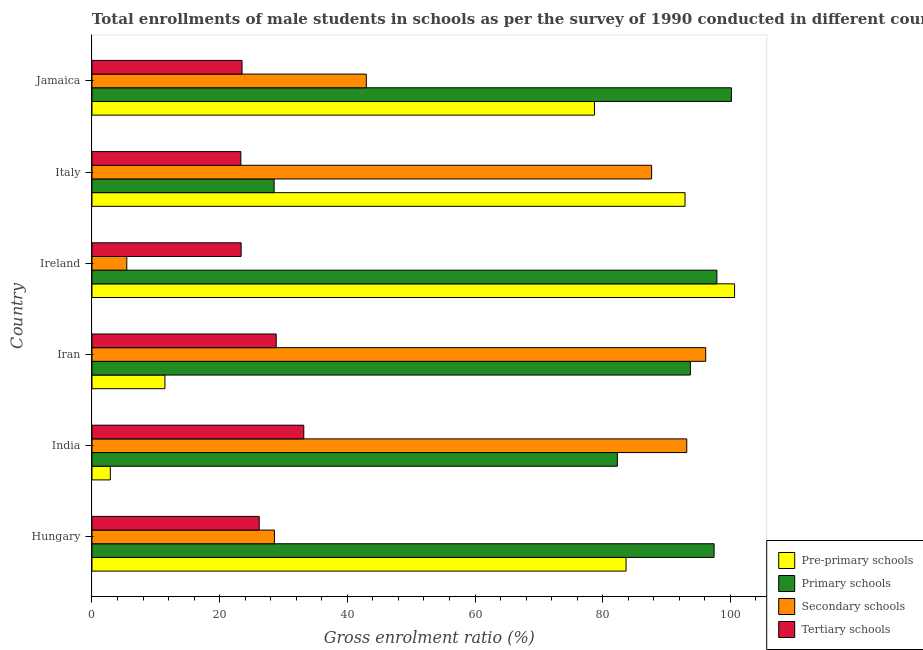Are the number of bars per tick equal to the number of legend labels?
Provide a succinct answer. Yes. Are the number of bars on each tick of the Y-axis equal?
Give a very brief answer. Yes. How many bars are there on the 1st tick from the top?
Give a very brief answer. 4. How many bars are there on the 4th tick from the bottom?
Provide a succinct answer. 4. What is the label of the 4th group of bars from the top?
Offer a terse response. Iran. In how many cases, is the number of bars for a given country not equal to the number of legend labels?
Your answer should be compact. 0. What is the gross enrolment ratio(male) in secondary schools in Italy?
Provide a succinct answer. 87.66. Across all countries, what is the maximum gross enrolment ratio(male) in pre-primary schools?
Provide a short and direct response. 100.66. Across all countries, what is the minimum gross enrolment ratio(male) in pre-primary schools?
Give a very brief answer. 2.87. In which country was the gross enrolment ratio(male) in pre-primary schools maximum?
Provide a short and direct response. Ireland. What is the total gross enrolment ratio(male) in primary schools in the graph?
Make the answer very short. 500.08. What is the difference between the gross enrolment ratio(male) in secondary schools in India and that in Ireland?
Offer a terse response. 87.72. What is the difference between the gross enrolment ratio(male) in pre-primary schools in Italy and the gross enrolment ratio(male) in secondary schools in India?
Offer a terse response. -0.27. What is the average gross enrolment ratio(male) in secondary schools per country?
Provide a short and direct response. 58.99. What is the difference between the gross enrolment ratio(male) in secondary schools and gross enrolment ratio(male) in pre-primary schools in Hungary?
Provide a succinct answer. -55.08. What is the ratio of the gross enrolment ratio(male) in pre-primary schools in Iran to that in Italy?
Your response must be concise. 0.12. Is the gross enrolment ratio(male) in primary schools in Iran less than that in Jamaica?
Ensure brevity in your answer.  Yes. Is the difference between the gross enrolment ratio(male) in secondary schools in Iran and Ireland greater than the difference between the gross enrolment ratio(male) in primary schools in Iran and Ireland?
Offer a very short reply. Yes. What is the difference between the highest and the second highest gross enrolment ratio(male) in tertiary schools?
Offer a very short reply. 4.32. What is the difference between the highest and the lowest gross enrolment ratio(male) in pre-primary schools?
Offer a very short reply. 97.78. In how many countries, is the gross enrolment ratio(male) in primary schools greater than the average gross enrolment ratio(male) in primary schools taken over all countries?
Give a very brief answer. 4. Is it the case that in every country, the sum of the gross enrolment ratio(male) in secondary schools and gross enrolment ratio(male) in tertiary schools is greater than the sum of gross enrolment ratio(male) in pre-primary schools and gross enrolment ratio(male) in primary schools?
Your answer should be compact. No. What does the 3rd bar from the top in Jamaica represents?
Provide a succinct answer. Primary schools. What does the 1st bar from the bottom in Ireland represents?
Offer a very short reply. Pre-primary schools. Is it the case that in every country, the sum of the gross enrolment ratio(male) in pre-primary schools and gross enrolment ratio(male) in primary schools is greater than the gross enrolment ratio(male) in secondary schools?
Provide a succinct answer. No. How many countries are there in the graph?
Offer a terse response. 6. Does the graph contain grids?
Offer a very short reply. No. How are the legend labels stacked?
Provide a succinct answer. Vertical. What is the title of the graph?
Give a very brief answer. Total enrollments of male students in schools as per the survey of 1990 conducted in different countries. Does "Bird species" appear as one of the legend labels in the graph?
Give a very brief answer. No. What is the label or title of the X-axis?
Provide a short and direct response. Gross enrolment ratio (%). What is the Gross enrolment ratio (%) in Pre-primary schools in Hungary?
Your answer should be very brief. 83.66. What is the Gross enrolment ratio (%) of Primary schools in Hungary?
Ensure brevity in your answer.  97.45. What is the Gross enrolment ratio (%) of Secondary schools in Hungary?
Provide a short and direct response. 28.58. What is the Gross enrolment ratio (%) of Tertiary schools in Hungary?
Keep it short and to the point. 26.19. What is the Gross enrolment ratio (%) of Pre-primary schools in India?
Your answer should be compact. 2.87. What is the Gross enrolment ratio (%) of Primary schools in India?
Your response must be concise. 82.3. What is the Gross enrolment ratio (%) in Secondary schools in India?
Offer a very short reply. 93.17. What is the Gross enrolment ratio (%) in Tertiary schools in India?
Your answer should be very brief. 33.18. What is the Gross enrolment ratio (%) in Pre-primary schools in Iran?
Offer a very short reply. 11.43. What is the Gross enrolment ratio (%) of Primary schools in Iran?
Ensure brevity in your answer.  93.74. What is the Gross enrolment ratio (%) in Secondary schools in Iran?
Provide a short and direct response. 96.13. What is the Gross enrolment ratio (%) in Tertiary schools in Iran?
Offer a very short reply. 28.86. What is the Gross enrolment ratio (%) of Pre-primary schools in Ireland?
Your response must be concise. 100.66. What is the Gross enrolment ratio (%) of Primary schools in Ireland?
Your response must be concise. 97.89. What is the Gross enrolment ratio (%) in Secondary schools in Ireland?
Offer a very short reply. 5.45. What is the Gross enrolment ratio (%) in Tertiary schools in Ireland?
Provide a succinct answer. 23.36. What is the Gross enrolment ratio (%) in Pre-primary schools in Italy?
Provide a succinct answer. 92.9. What is the Gross enrolment ratio (%) in Primary schools in Italy?
Make the answer very short. 28.54. What is the Gross enrolment ratio (%) in Secondary schools in Italy?
Your response must be concise. 87.66. What is the Gross enrolment ratio (%) of Tertiary schools in Italy?
Your response must be concise. 23.32. What is the Gross enrolment ratio (%) of Pre-primary schools in Jamaica?
Offer a terse response. 78.71. What is the Gross enrolment ratio (%) in Primary schools in Jamaica?
Offer a very short reply. 100.16. What is the Gross enrolment ratio (%) in Secondary schools in Jamaica?
Make the answer very short. 42.97. What is the Gross enrolment ratio (%) in Tertiary schools in Jamaica?
Offer a terse response. 23.51. Across all countries, what is the maximum Gross enrolment ratio (%) in Pre-primary schools?
Give a very brief answer. 100.66. Across all countries, what is the maximum Gross enrolment ratio (%) in Primary schools?
Give a very brief answer. 100.16. Across all countries, what is the maximum Gross enrolment ratio (%) in Secondary schools?
Provide a short and direct response. 96.13. Across all countries, what is the maximum Gross enrolment ratio (%) in Tertiary schools?
Offer a terse response. 33.18. Across all countries, what is the minimum Gross enrolment ratio (%) of Pre-primary schools?
Your response must be concise. 2.87. Across all countries, what is the minimum Gross enrolment ratio (%) in Primary schools?
Provide a short and direct response. 28.54. Across all countries, what is the minimum Gross enrolment ratio (%) in Secondary schools?
Ensure brevity in your answer.  5.45. Across all countries, what is the minimum Gross enrolment ratio (%) of Tertiary schools?
Keep it short and to the point. 23.32. What is the total Gross enrolment ratio (%) of Pre-primary schools in the graph?
Keep it short and to the point. 370.22. What is the total Gross enrolment ratio (%) in Primary schools in the graph?
Your response must be concise. 500.08. What is the total Gross enrolment ratio (%) of Secondary schools in the graph?
Keep it short and to the point. 353.97. What is the total Gross enrolment ratio (%) in Tertiary schools in the graph?
Offer a very short reply. 158.42. What is the difference between the Gross enrolment ratio (%) in Pre-primary schools in Hungary and that in India?
Provide a succinct answer. 80.78. What is the difference between the Gross enrolment ratio (%) in Primary schools in Hungary and that in India?
Your answer should be very brief. 15.15. What is the difference between the Gross enrolment ratio (%) in Secondary schools in Hungary and that in India?
Offer a very short reply. -64.59. What is the difference between the Gross enrolment ratio (%) in Tertiary schools in Hungary and that in India?
Provide a short and direct response. -6.98. What is the difference between the Gross enrolment ratio (%) of Pre-primary schools in Hungary and that in Iran?
Ensure brevity in your answer.  72.23. What is the difference between the Gross enrolment ratio (%) of Primary schools in Hungary and that in Iran?
Make the answer very short. 3.71. What is the difference between the Gross enrolment ratio (%) in Secondary schools in Hungary and that in Iran?
Keep it short and to the point. -67.56. What is the difference between the Gross enrolment ratio (%) in Tertiary schools in Hungary and that in Iran?
Provide a succinct answer. -2.66. What is the difference between the Gross enrolment ratio (%) in Pre-primary schools in Hungary and that in Ireland?
Offer a terse response. -17. What is the difference between the Gross enrolment ratio (%) in Primary schools in Hungary and that in Ireland?
Your answer should be very brief. -0.44. What is the difference between the Gross enrolment ratio (%) in Secondary schools in Hungary and that in Ireland?
Your answer should be compact. 23.12. What is the difference between the Gross enrolment ratio (%) of Tertiary schools in Hungary and that in Ireland?
Keep it short and to the point. 2.83. What is the difference between the Gross enrolment ratio (%) of Pre-primary schools in Hungary and that in Italy?
Provide a succinct answer. -9.24. What is the difference between the Gross enrolment ratio (%) of Primary schools in Hungary and that in Italy?
Your response must be concise. 68.91. What is the difference between the Gross enrolment ratio (%) of Secondary schools in Hungary and that in Italy?
Offer a very short reply. -59.09. What is the difference between the Gross enrolment ratio (%) of Tertiary schools in Hungary and that in Italy?
Offer a terse response. 2.87. What is the difference between the Gross enrolment ratio (%) in Pre-primary schools in Hungary and that in Jamaica?
Your answer should be compact. 4.95. What is the difference between the Gross enrolment ratio (%) in Primary schools in Hungary and that in Jamaica?
Provide a succinct answer. -2.71. What is the difference between the Gross enrolment ratio (%) in Secondary schools in Hungary and that in Jamaica?
Ensure brevity in your answer.  -14.39. What is the difference between the Gross enrolment ratio (%) in Tertiary schools in Hungary and that in Jamaica?
Offer a terse response. 2.69. What is the difference between the Gross enrolment ratio (%) of Pre-primary schools in India and that in Iran?
Your response must be concise. -8.55. What is the difference between the Gross enrolment ratio (%) of Primary schools in India and that in Iran?
Ensure brevity in your answer.  -11.44. What is the difference between the Gross enrolment ratio (%) in Secondary schools in India and that in Iran?
Provide a succinct answer. -2.97. What is the difference between the Gross enrolment ratio (%) in Tertiary schools in India and that in Iran?
Provide a succinct answer. 4.32. What is the difference between the Gross enrolment ratio (%) of Pre-primary schools in India and that in Ireland?
Provide a short and direct response. -97.78. What is the difference between the Gross enrolment ratio (%) in Primary schools in India and that in Ireland?
Your answer should be very brief. -15.59. What is the difference between the Gross enrolment ratio (%) of Secondary schools in India and that in Ireland?
Your response must be concise. 87.71. What is the difference between the Gross enrolment ratio (%) in Tertiary schools in India and that in Ireland?
Your answer should be very brief. 9.81. What is the difference between the Gross enrolment ratio (%) of Pre-primary schools in India and that in Italy?
Give a very brief answer. -90.02. What is the difference between the Gross enrolment ratio (%) of Primary schools in India and that in Italy?
Ensure brevity in your answer.  53.77. What is the difference between the Gross enrolment ratio (%) of Secondary schools in India and that in Italy?
Your answer should be compact. 5.51. What is the difference between the Gross enrolment ratio (%) of Tertiary schools in India and that in Italy?
Provide a succinct answer. 9.85. What is the difference between the Gross enrolment ratio (%) of Pre-primary schools in India and that in Jamaica?
Keep it short and to the point. -75.84. What is the difference between the Gross enrolment ratio (%) in Primary schools in India and that in Jamaica?
Your answer should be compact. -17.86. What is the difference between the Gross enrolment ratio (%) in Secondary schools in India and that in Jamaica?
Provide a short and direct response. 50.2. What is the difference between the Gross enrolment ratio (%) of Tertiary schools in India and that in Jamaica?
Ensure brevity in your answer.  9.67. What is the difference between the Gross enrolment ratio (%) of Pre-primary schools in Iran and that in Ireland?
Offer a terse response. -89.23. What is the difference between the Gross enrolment ratio (%) in Primary schools in Iran and that in Ireland?
Make the answer very short. -4.15. What is the difference between the Gross enrolment ratio (%) in Secondary schools in Iran and that in Ireland?
Give a very brief answer. 90.68. What is the difference between the Gross enrolment ratio (%) in Tertiary schools in Iran and that in Ireland?
Your answer should be very brief. 5.49. What is the difference between the Gross enrolment ratio (%) of Pre-primary schools in Iran and that in Italy?
Keep it short and to the point. -81.47. What is the difference between the Gross enrolment ratio (%) in Primary schools in Iran and that in Italy?
Give a very brief answer. 65.2. What is the difference between the Gross enrolment ratio (%) in Secondary schools in Iran and that in Italy?
Provide a short and direct response. 8.47. What is the difference between the Gross enrolment ratio (%) in Tertiary schools in Iran and that in Italy?
Your response must be concise. 5.54. What is the difference between the Gross enrolment ratio (%) of Pre-primary schools in Iran and that in Jamaica?
Your response must be concise. -67.28. What is the difference between the Gross enrolment ratio (%) of Primary schools in Iran and that in Jamaica?
Provide a succinct answer. -6.42. What is the difference between the Gross enrolment ratio (%) in Secondary schools in Iran and that in Jamaica?
Offer a terse response. 53.16. What is the difference between the Gross enrolment ratio (%) in Tertiary schools in Iran and that in Jamaica?
Offer a terse response. 5.35. What is the difference between the Gross enrolment ratio (%) in Pre-primary schools in Ireland and that in Italy?
Provide a short and direct response. 7.76. What is the difference between the Gross enrolment ratio (%) in Primary schools in Ireland and that in Italy?
Ensure brevity in your answer.  69.36. What is the difference between the Gross enrolment ratio (%) of Secondary schools in Ireland and that in Italy?
Give a very brief answer. -82.21. What is the difference between the Gross enrolment ratio (%) in Tertiary schools in Ireland and that in Italy?
Offer a terse response. 0.04. What is the difference between the Gross enrolment ratio (%) in Pre-primary schools in Ireland and that in Jamaica?
Your answer should be compact. 21.95. What is the difference between the Gross enrolment ratio (%) in Primary schools in Ireland and that in Jamaica?
Offer a terse response. -2.27. What is the difference between the Gross enrolment ratio (%) of Secondary schools in Ireland and that in Jamaica?
Give a very brief answer. -37.52. What is the difference between the Gross enrolment ratio (%) of Tertiary schools in Ireland and that in Jamaica?
Offer a very short reply. -0.14. What is the difference between the Gross enrolment ratio (%) of Pre-primary schools in Italy and that in Jamaica?
Keep it short and to the point. 14.19. What is the difference between the Gross enrolment ratio (%) in Primary schools in Italy and that in Jamaica?
Your answer should be very brief. -71.63. What is the difference between the Gross enrolment ratio (%) in Secondary schools in Italy and that in Jamaica?
Keep it short and to the point. 44.69. What is the difference between the Gross enrolment ratio (%) in Tertiary schools in Italy and that in Jamaica?
Your answer should be compact. -0.18. What is the difference between the Gross enrolment ratio (%) in Pre-primary schools in Hungary and the Gross enrolment ratio (%) in Primary schools in India?
Keep it short and to the point. 1.36. What is the difference between the Gross enrolment ratio (%) of Pre-primary schools in Hungary and the Gross enrolment ratio (%) of Secondary schools in India?
Offer a very short reply. -9.51. What is the difference between the Gross enrolment ratio (%) in Pre-primary schools in Hungary and the Gross enrolment ratio (%) in Tertiary schools in India?
Your response must be concise. 50.48. What is the difference between the Gross enrolment ratio (%) of Primary schools in Hungary and the Gross enrolment ratio (%) of Secondary schools in India?
Provide a short and direct response. 4.28. What is the difference between the Gross enrolment ratio (%) of Primary schools in Hungary and the Gross enrolment ratio (%) of Tertiary schools in India?
Give a very brief answer. 64.27. What is the difference between the Gross enrolment ratio (%) in Secondary schools in Hungary and the Gross enrolment ratio (%) in Tertiary schools in India?
Provide a short and direct response. -4.6. What is the difference between the Gross enrolment ratio (%) of Pre-primary schools in Hungary and the Gross enrolment ratio (%) of Primary schools in Iran?
Offer a terse response. -10.08. What is the difference between the Gross enrolment ratio (%) in Pre-primary schools in Hungary and the Gross enrolment ratio (%) in Secondary schools in Iran?
Your answer should be very brief. -12.48. What is the difference between the Gross enrolment ratio (%) in Pre-primary schools in Hungary and the Gross enrolment ratio (%) in Tertiary schools in Iran?
Offer a very short reply. 54.8. What is the difference between the Gross enrolment ratio (%) of Primary schools in Hungary and the Gross enrolment ratio (%) of Secondary schools in Iran?
Ensure brevity in your answer.  1.31. What is the difference between the Gross enrolment ratio (%) of Primary schools in Hungary and the Gross enrolment ratio (%) of Tertiary schools in Iran?
Your answer should be compact. 68.59. What is the difference between the Gross enrolment ratio (%) in Secondary schools in Hungary and the Gross enrolment ratio (%) in Tertiary schools in Iran?
Provide a succinct answer. -0.28. What is the difference between the Gross enrolment ratio (%) of Pre-primary schools in Hungary and the Gross enrolment ratio (%) of Primary schools in Ireland?
Give a very brief answer. -14.23. What is the difference between the Gross enrolment ratio (%) of Pre-primary schools in Hungary and the Gross enrolment ratio (%) of Secondary schools in Ireland?
Your answer should be compact. 78.2. What is the difference between the Gross enrolment ratio (%) in Pre-primary schools in Hungary and the Gross enrolment ratio (%) in Tertiary schools in Ireland?
Make the answer very short. 60.29. What is the difference between the Gross enrolment ratio (%) of Primary schools in Hungary and the Gross enrolment ratio (%) of Secondary schools in Ireland?
Make the answer very short. 92. What is the difference between the Gross enrolment ratio (%) in Primary schools in Hungary and the Gross enrolment ratio (%) in Tertiary schools in Ireland?
Give a very brief answer. 74.09. What is the difference between the Gross enrolment ratio (%) in Secondary schools in Hungary and the Gross enrolment ratio (%) in Tertiary schools in Ireland?
Your response must be concise. 5.21. What is the difference between the Gross enrolment ratio (%) of Pre-primary schools in Hungary and the Gross enrolment ratio (%) of Primary schools in Italy?
Make the answer very short. 55.12. What is the difference between the Gross enrolment ratio (%) of Pre-primary schools in Hungary and the Gross enrolment ratio (%) of Secondary schools in Italy?
Your answer should be compact. -4. What is the difference between the Gross enrolment ratio (%) of Pre-primary schools in Hungary and the Gross enrolment ratio (%) of Tertiary schools in Italy?
Give a very brief answer. 60.34. What is the difference between the Gross enrolment ratio (%) in Primary schools in Hungary and the Gross enrolment ratio (%) in Secondary schools in Italy?
Offer a terse response. 9.79. What is the difference between the Gross enrolment ratio (%) in Primary schools in Hungary and the Gross enrolment ratio (%) in Tertiary schools in Italy?
Your answer should be compact. 74.13. What is the difference between the Gross enrolment ratio (%) in Secondary schools in Hungary and the Gross enrolment ratio (%) in Tertiary schools in Italy?
Make the answer very short. 5.25. What is the difference between the Gross enrolment ratio (%) in Pre-primary schools in Hungary and the Gross enrolment ratio (%) in Primary schools in Jamaica?
Provide a short and direct response. -16.5. What is the difference between the Gross enrolment ratio (%) of Pre-primary schools in Hungary and the Gross enrolment ratio (%) of Secondary schools in Jamaica?
Provide a succinct answer. 40.69. What is the difference between the Gross enrolment ratio (%) of Pre-primary schools in Hungary and the Gross enrolment ratio (%) of Tertiary schools in Jamaica?
Your response must be concise. 60.15. What is the difference between the Gross enrolment ratio (%) in Primary schools in Hungary and the Gross enrolment ratio (%) in Secondary schools in Jamaica?
Your answer should be compact. 54.48. What is the difference between the Gross enrolment ratio (%) in Primary schools in Hungary and the Gross enrolment ratio (%) in Tertiary schools in Jamaica?
Your answer should be very brief. 73.94. What is the difference between the Gross enrolment ratio (%) of Secondary schools in Hungary and the Gross enrolment ratio (%) of Tertiary schools in Jamaica?
Ensure brevity in your answer.  5.07. What is the difference between the Gross enrolment ratio (%) of Pre-primary schools in India and the Gross enrolment ratio (%) of Primary schools in Iran?
Provide a succinct answer. -90.86. What is the difference between the Gross enrolment ratio (%) of Pre-primary schools in India and the Gross enrolment ratio (%) of Secondary schools in Iran?
Give a very brief answer. -93.26. What is the difference between the Gross enrolment ratio (%) in Pre-primary schools in India and the Gross enrolment ratio (%) in Tertiary schools in Iran?
Provide a succinct answer. -25.98. What is the difference between the Gross enrolment ratio (%) of Primary schools in India and the Gross enrolment ratio (%) of Secondary schools in Iran?
Keep it short and to the point. -13.83. What is the difference between the Gross enrolment ratio (%) of Primary schools in India and the Gross enrolment ratio (%) of Tertiary schools in Iran?
Your answer should be compact. 53.44. What is the difference between the Gross enrolment ratio (%) of Secondary schools in India and the Gross enrolment ratio (%) of Tertiary schools in Iran?
Your answer should be compact. 64.31. What is the difference between the Gross enrolment ratio (%) of Pre-primary schools in India and the Gross enrolment ratio (%) of Primary schools in Ireland?
Provide a short and direct response. -95.02. What is the difference between the Gross enrolment ratio (%) of Pre-primary schools in India and the Gross enrolment ratio (%) of Secondary schools in Ireland?
Provide a succinct answer. -2.58. What is the difference between the Gross enrolment ratio (%) of Pre-primary schools in India and the Gross enrolment ratio (%) of Tertiary schools in Ireland?
Provide a succinct answer. -20.49. What is the difference between the Gross enrolment ratio (%) of Primary schools in India and the Gross enrolment ratio (%) of Secondary schools in Ireland?
Provide a succinct answer. 76.85. What is the difference between the Gross enrolment ratio (%) of Primary schools in India and the Gross enrolment ratio (%) of Tertiary schools in Ireland?
Make the answer very short. 58.94. What is the difference between the Gross enrolment ratio (%) in Secondary schools in India and the Gross enrolment ratio (%) in Tertiary schools in Ireland?
Ensure brevity in your answer.  69.81. What is the difference between the Gross enrolment ratio (%) in Pre-primary schools in India and the Gross enrolment ratio (%) in Primary schools in Italy?
Ensure brevity in your answer.  -25.66. What is the difference between the Gross enrolment ratio (%) in Pre-primary schools in India and the Gross enrolment ratio (%) in Secondary schools in Italy?
Provide a succinct answer. -84.79. What is the difference between the Gross enrolment ratio (%) of Pre-primary schools in India and the Gross enrolment ratio (%) of Tertiary schools in Italy?
Offer a very short reply. -20.45. What is the difference between the Gross enrolment ratio (%) in Primary schools in India and the Gross enrolment ratio (%) in Secondary schools in Italy?
Your answer should be compact. -5.36. What is the difference between the Gross enrolment ratio (%) in Primary schools in India and the Gross enrolment ratio (%) in Tertiary schools in Italy?
Provide a succinct answer. 58.98. What is the difference between the Gross enrolment ratio (%) of Secondary schools in India and the Gross enrolment ratio (%) of Tertiary schools in Italy?
Your answer should be compact. 69.85. What is the difference between the Gross enrolment ratio (%) of Pre-primary schools in India and the Gross enrolment ratio (%) of Primary schools in Jamaica?
Your answer should be very brief. -97.29. What is the difference between the Gross enrolment ratio (%) in Pre-primary schools in India and the Gross enrolment ratio (%) in Secondary schools in Jamaica?
Keep it short and to the point. -40.1. What is the difference between the Gross enrolment ratio (%) of Pre-primary schools in India and the Gross enrolment ratio (%) of Tertiary schools in Jamaica?
Ensure brevity in your answer.  -20.63. What is the difference between the Gross enrolment ratio (%) in Primary schools in India and the Gross enrolment ratio (%) in Secondary schools in Jamaica?
Your answer should be very brief. 39.33. What is the difference between the Gross enrolment ratio (%) of Primary schools in India and the Gross enrolment ratio (%) of Tertiary schools in Jamaica?
Give a very brief answer. 58.79. What is the difference between the Gross enrolment ratio (%) of Secondary schools in India and the Gross enrolment ratio (%) of Tertiary schools in Jamaica?
Your answer should be very brief. 69.66. What is the difference between the Gross enrolment ratio (%) of Pre-primary schools in Iran and the Gross enrolment ratio (%) of Primary schools in Ireland?
Offer a very short reply. -86.46. What is the difference between the Gross enrolment ratio (%) in Pre-primary schools in Iran and the Gross enrolment ratio (%) in Secondary schools in Ireland?
Give a very brief answer. 5.97. What is the difference between the Gross enrolment ratio (%) in Pre-primary schools in Iran and the Gross enrolment ratio (%) in Tertiary schools in Ireland?
Offer a very short reply. -11.93. What is the difference between the Gross enrolment ratio (%) of Primary schools in Iran and the Gross enrolment ratio (%) of Secondary schools in Ireland?
Ensure brevity in your answer.  88.28. What is the difference between the Gross enrolment ratio (%) of Primary schools in Iran and the Gross enrolment ratio (%) of Tertiary schools in Ireland?
Offer a terse response. 70.37. What is the difference between the Gross enrolment ratio (%) of Secondary schools in Iran and the Gross enrolment ratio (%) of Tertiary schools in Ireland?
Make the answer very short. 72.77. What is the difference between the Gross enrolment ratio (%) of Pre-primary schools in Iran and the Gross enrolment ratio (%) of Primary schools in Italy?
Give a very brief answer. -17.11. What is the difference between the Gross enrolment ratio (%) of Pre-primary schools in Iran and the Gross enrolment ratio (%) of Secondary schools in Italy?
Provide a succinct answer. -76.23. What is the difference between the Gross enrolment ratio (%) of Pre-primary schools in Iran and the Gross enrolment ratio (%) of Tertiary schools in Italy?
Give a very brief answer. -11.89. What is the difference between the Gross enrolment ratio (%) of Primary schools in Iran and the Gross enrolment ratio (%) of Secondary schools in Italy?
Make the answer very short. 6.08. What is the difference between the Gross enrolment ratio (%) of Primary schools in Iran and the Gross enrolment ratio (%) of Tertiary schools in Italy?
Offer a terse response. 70.42. What is the difference between the Gross enrolment ratio (%) in Secondary schools in Iran and the Gross enrolment ratio (%) in Tertiary schools in Italy?
Provide a short and direct response. 72.81. What is the difference between the Gross enrolment ratio (%) in Pre-primary schools in Iran and the Gross enrolment ratio (%) in Primary schools in Jamaica?
Give a very brief answer. -88.73. What is the difference between the Gross enrolment ratio (%) in Pre-primary schools in Iran and the Gross enrolment ratio (%) in Secondary schools in Jamaica?
Provide a succinct answer. -31.54. What is the difference between the Gross enrolment ratio (%) in Pre-primary schools in Iran and the Gross enrolment ratio (%) in Tertiary schools in Jamaica?
Your answer should be compact. -12.08. What is the difference between the Gross enrolment ratio (%) of Primary schools in Iran and the Gross enrolment ratio (%) of Secondary schools in Jamaica?
Keep it short and to the point. 50.77. What is the difference between the Gross enrolment ratio (%) of Primary schools in Iran and the Gross enrolment ratio (%) of Tertiary schools in Jamaica?
Your answer should be compact. 70.23. What is the difference between the Gross enrolment ratio (%) in Secondary schools in Iran and the Gross enrolment ratio (%) in Tertiary schools in Jamaica?
Provide a succinct answer. 72.63. What is the difference between the Gross enrolment ratio (%) in Pre-primary schools in Ireland and the Gross enrolment ratio (%) in Primary schools in Italy?
Your answer should be very brief. 72.12. What is the difference between the Gross enrolment ratio (%) in Pre-primary schools in Ireland and the Gross enrolment ratio (%) in Secondary schools in Italy?
Your answer should be compact. 12.99. What is the difference between the Gross enrolment ratio (%) of Pre-primary schools in Ireland and the Gross enrolment ratio (%) of Tertiary schools in Italy?
Keep it short and to the point. 77.34. What is the difference between the Gross enrolment ratio (%) in Primary schools in Ireland and the Gross enrolment ratio (%) in Secondary schools in Italy?
Offer a very short reply. 10.23. What is the difference between the Gross enrolment ratio (%) in Primary schools in Ireland and the Gross enrolment ratio (%) in Tertiary schools in Italy?
Your response must be concise. 74.57. What is the difference between the Gross enrolment ratio (%) of Secondary schools in Ireland and the Gross enrolment ratio (%) of Tertiary schools in Italy?
Your response must be concise. -17.87. What is the difference between the Gross enrolment ratio (%) in Pre-primary schools in Ireland and the Gross enrolment ratio (%) in Primary schools in Jamaica?
Provide a succinct answer. 0.5. What is the difference between the Gross enrolment ratio (%) of Pre-primary schools in Ireland and the Gross enrolment ratio (%) of Secondary schools in Jamaica?
Offer a terse response. 57.69. What is the difference between the Gross enrolment ratio (%) in Pre-primary schools in Ireland and the Gross enrolment ratio (%) in Tertiary schools in Jamaica?
Your answer should be very brief. 77.15. What is the difference between the Gross enrolment ratio (%) in Primary schools in Ireland and the Gross enrolment ratio (%) in Secondary schools in Jamaica?
Provide a short and direct response. 54.92. What is the difference between the Gross enrolment ratio (%) of Primary schools in Ireland and the Gross enrolment ratio (%) of Tertiary schools in Jamaica?
Offer a very short reply. 74.39. What is the difference between the Gross enrolment ratio (%) of Secondary schools in Ireland and the Gross enrolment ratio (%) of Tertiary schools in Jamaica?
Provide a succinct answer. -18.05. What is the difference between the Gross enrolment ratio (%) of Pre-primary schools in Italy and the Gross enrolment ratio (%) of Primary schools in Jamaica?
Keep it short and to the point. -7.26. What is the difference between the Gross enrolment ratio (%) of Pre-primary schools in Italy and the Gross enrolment ratio (%) of Secondary schools in Jamaica?
Provide a short and direct response. 49.93. What is the difference between the Gross enrolment ratio (%) of Pre-primary schools in Italy and the Gross enrolment ratio (%) of Tertiary schools in Jamaica?
Keep it short and to the point. 69.39. What is the difference between the Gross enrolment ratio (%) of Primary schools in Italy and the Gross enrolment ratio (%) of Secondary schools in Jamaica?
Ensure brevity in your answer.  -14.44. What is the difference between the Gross enrolment ratio (%) of Primary schools in Italy and the Gross enrolment ratio (%) of Tertiary schools in Jamaica?
Provide a short and direct response. 5.03. What is the difference between the Gross enrolment ratio (%) in Secondary schools in Italy and the Gross enrolment ratio (%) in Tertiary schools in Jamaica?
Your answer should be very brief. 64.16. What is the average Gross enrolment ratio (%) of Pre-primary schools per country?
Provide a short and direct response. 61.7. What is the average Gross enrolment ratio (%) in Primary schools per country?
Make the answer very short. 83.35. What is the average Gross enrolment ratio (%) of Secondary schools per country?
Give a very brief answer. 58.99. What is the average Gross enrolment ratio (%) in Tertiary schools per country?
Provide a short and direct response. 26.4. What is the difference between the Gross enrolment ratio (%) in Pre-primary schools and Gross enrolment ratio (%) in Primary schools in Hungary?
Make the answer very short. -13.79. What is the difference between the Gross enrolment ratio (%) in Pre-primary schools and Gross enrolment ratio (%) in Secondary schools in Hungary?
Your answer should be compact. 55.08. What is the difference between the Gross enrolment ratio (%) of Pre-primary schools and Gross enrolment ratio (%) of Tertiary schools in Hungary?
Your response must be concise. 57.46. What is the difference between the Gross enrolment ratio (%) in Primary schools and Gross enrolment ratio (%) in Secondary schools in Hungary?
Offer a very short reply. 68.87. What is the difference between the Gross enrolment ratio (%) of Primary schools and Gross enrolment ratio (%) of Tertiary schools in Hungary?
Provide a succinct answer. 71.26. What is the difference between the Gross enrolment ratio (%) of Secondary schools and Gross enrolment ratio (%) of Tertiary schools in Hungary?
Provide a short and direct response. 2.38. What is the difference between the Gross enrolment ratio (%) in Pre-primary schools and Gross enrolment ratio (%) in Primary schools in India?
Offer a very short reply. -79.43. What is the difference between the Gross enrolment ratio (%) of Pre-primary schools and Gross enrolment ratio (%) of Secondary schools in India?
Keep it short and to the point. -90.3. What is the difference between the Gross enrolment ratio (%) of Pre-primary schools and Gross enrolment ratio (%) of Tertiary schools in India?
Your answer should be compact. -30.3. What is the difference between the Gross enrolment ratio (%) in Primary schools and Gross enrolment ratio (%) in Secondary schools in India?
Keep it short and to the point. -10.87. What is the difference between the Gross enrolment ratio (%) of Primary schools and Gross enrolment ratio (%) of Tertiary schools in India?
Offer a very short reply. 49.12. What is the difference between the Gross enrolment ratio (%) of Secondary schools and Gross enrolment ratio (%) of Tertiary schools in India?
Provide a succinct answer. 59.99. What is the difference between the Gross enrolment ratio (%) of Pre-primary schools and Gross enrolment ratio (%) of Primary schools in Iran?
Your answer should be very brief. -82.31. What is the difference between the Gross enrolment ratio (%) of Pre-primary schools and Gross enrolment ratio (%) of Secondary schools in Iran?
Offer a very short reply. -84.71. What is the difference between the Gross enrolment ratio (%) of Pre-primary schools and Gross enrolment ratio (%) of Tertiary schools in Iran?
Your answer should be very brief. -17.43. What is the difference between the Gross enrolment ratio (%) in Primary schools and Gross enrolment ratio (%) in Secondary schools in Iran?
Offer a terse response. -2.4. What is the difference between the Gross enrolment ratio (%) of Primary schools and Gross enrolment ratio (%) of Tertiary schools in Iran?
Provide a succinct answer. 64.88. What is the difference between the Gross enrolment ratio (%) of Secondary schools and Gross enrolment ratio (%) of Tertiary schools in Iran?
Keep it short and to the point. 67.28. What is the difference between the Gross enrolment ratio (%) of Pre-primary schools and Gross enrolment ratio (%) of Primary schools in Ireland?
Make the answer very short. 2.77. What is the difference between the Gross enrolment ratio (%) in Pre-primary schools and Gross enrolment ratio (%) in Secondary schools in Ireland?
Provide a succinct answer. 95.2. What is the difference between the Gross enrolment ratio (%) of Pre-primary schools and Gross enrolment ratio (%) of Tertiary schools in Ireland?
Give a very brief answer. 77.29. What is the difference between the Gross enrolment ratio (%) in Primary schools and Gross enrolment ratio (%) in Secondary schools in Ireland?
Your answer should be very brief. 92.44. What is the difference between the Gross enrolment ratio (%) of Primary schools and Gross enrolment ratio (%) of Tertiary schools in Ireland?
Make the answer very short. 74.53. What is the difference between the Gross enrolment ratio (%) in Secondary schools and Gross enrolment ratio (%) in Tertiary schools in Ireland?
Offer a terse response. -17.91. What is the difference between the Gross enrolment ratio (%) in Pre-primary schools and Gross enrolment ratio (%) in Primary schools in Italy?
Make the answer very short. 64.36. What is the difference between the Gross enrolment ratio (%) of Pre-primary schools and Gross enrolment ratio (%) of Secondary schools in Italy?
Your response must be concise. 5.24. What is the difference between the Gross enrolment ratio (%) in Pre-primary schools and Gross enrolment ratio (%) in Tertiary schools in Italy?
Ensure brevity in your answer.  69.58. What is the difference between the Gross enrolment ratio (%) of Primary schools and Gross enrolment ratio (%) of Secondary schools in Italy?
Give a very brief answer. -59.13. What is the difference between the Gross enrolment ratio (%) of Primary schools and Gross enrolment ratio (%) of Tertiary schools in Italy?
Your response must be concise. 5.21. What is the difference between the Gross enrolment ratio (%) of Secondary schools and Gross enrolment ratio (%) of Tertiary schools in Italy?
Offer a terse response. 64.34. What is the difference between the Gross enrolment ratio (%) of Pre-primary schools and Gross enrolment ratio (%) of Primary schools in Jamaica?
Your response must be concise. -21.45. What is the difference between the Gross enrolment ratio (%) of Pre-primary schools and Gross enrolment ratio (%) of Secondary schools in Jamaica?
Offer a terse response. 35.74. What is the difference between the Gross enrolment ratio (%) in Pre-primary schools and Gross enrolment ratio (%) in Tertiary schools in Jamaica?
Offer a very short reply. 55.2. What is the difference between the Gross enrolment ratio (%) in Primary schools and Gross enrolment ratio (%) in Secondary schools in Jamaica?
Offer a very short reply. 57.19. What is the difference between the Gross enrolment ratio (%) of Primary schools and Gross enrolment ratio (%) of Tertiary schools in Jamaica?
Your answer should be very brief. 76.66. What is the difference between the Gross enrolment ratio (%) of Secondary schools and Gross enrolment ratio (%) of Tertiary schools in Jamaica?
Your answer should be compact. 19.46. What is the ratio of the Gross enrolment ratio (%) in Pre-primary schools in Hungary to that in India?
Ensure brevity in your answer.  29.11. What is the ratio of the Gross enrolment ratio (%) of Primary schools in Hungary to that in India?
Offer a terse response. 1.18. What is the ratio of the Gross enrolment ratio (%) of Secondary schools in Hungary to that in India?
Your answer should be compact. 0.31. What is the ratio of the Gross enrolment ratio (%) in Tertiary schools in Hungary to that in India?
Ensure brevity in your answer.  0.79. What is the ratio of the Gross enrolment ratio (%) of Pre-primary schools in Hungary to that in Iran?
Give a very brief answer. 7.32. What is the ratio of the Gross enrolment ratio (%) in Primary schools in Hungary to that in Iran?
Your response must be concise. 1.04. What is the ratio of the Gross enrolment ratio (%) of Secondary schools in Hungary to that in Iran?
Ensure brevity in your answer.  0.3. What is the ratio of the Gross enrolment ratio (%) of Tertiary schools in Hungary to that in Iran?
Your answer should be compact. 0.91. What is the ratio of the Gross enrolment ratio (%) in Pre-primary schools in Hungary to that in Ireland?
Provide a succinct answer. 0.83. What is the ratio of the Gross enrolment ratio (%) of Primary schools in Hungary to that in Ireland?
Give a very brief answer. 1. What is the ratio of the Gross enrolment ratio (%) in Secondary schools in Hungary to that in Ireland?
Provide a short and direct response. 5.24. What is the ratio of the Gross enrolment ratio (%) of Tertiary schools in Hungary to that in Ireland?
Provide a succinct answer. 1.12. What is the ratio of the Gross enrolment ratio (%) in Pre-primary schools in Hungary to that in Italy?
Offer a very short reply. 0.9. What is the ratio of the Gross enrolment ratio (%) in Primary schools in Hungary to that in Italy?
Your answer should be compact. 3.42. What is the ratio of the Gross enrolment ratio (%) in Secondary schools in Hungary to that in Italy?
Ensure brevity in your answer.  0.33. What is the ratio of the Gross enrolment ratio (%) in Tertiary schools in Hungary to that in Italy?
Keep it short and to the point. 1.12. What is the ratio of the Gross enrolment ratio (%) of Pre-primary schools in Hungary to that in Jamaica?
Give a very brief answer. 1.06. What is the ratio of the Gross enrolment ratio (%) of Primary schools in Hungary to that in Jamaica?
Offer a terse response. 0.97. What is the ratio of the Gross enrolment ratio (%) of Secondary schools in Hungary to that in Jamaica?
Ensure brevity in your answer.  0.67. What is the ratio of the Gross enrolment ratio (%) in Tertiary schools in Hungary to that in Jamaica?
Your answer should be very brief. 1.11. What is the ratio of the Gross enrolment ratio (%) of Pre-primary schools in India to that in Iran?
Your response must be concise. 0.25. What is the ratio of the Gross enrolment ratio (%) in Primary schools in India to that in Iran?
Offer a terse response. 0.88. What is the ratio of the Gross enrolment ratio (%) in Secondary schools in India to that in Iran?
Make the answer very short. 0.97. What is the ratio of the Gross enrolment ratio (%) of Tertiary schools in India to that in Iran?
Keep it short and to the point. 1.15. What is the ratio of the Gross enrolment ratio (%) of Pre-primary schools in India to that in Ireland?
Give a very brief answer. 0.03. What is the ratio of the Gross enrolment ratio (%) of Primary schools in India to that in Ireland?
Give a very brief answer. 0.84. What is the ratio of the Gross enrolment ratio (%) in Secondary schools in India to that in Ireland?
Your answer should be very brief. 17.08. What is the ratio of the Gross enrolment ratio (%) in Tertiary schools in India to that in Ireland?
Ensure brevity in your answer.  1.42. What is the ratio of the Gross enrolment ratio (%) in Pre-primary schools in India to that in Italy?
Make the answer very short. 0.03. What is the ratio of the Gross enrolment ratio (%) of Primary schools in India to that in Italy?
Your response must be concise. 2.88. What is the ratio of the Gross enrolment ratio (%) of Secondary schools in India to that in Italy?
Give a very brief answer. 1.06. What is the ratio of the Gross enrolment ratio (%) of Tertiary schools in India to that in Italy?
Provide a succinct answer. 1.42. What is the ratio of the Gross enrolment ratio (%) in Pre-primary schools in India to that in Jamaica?
Your response must be concise. 0.04. What is the ratio of the Gross enrolment ratio (%) in Primary schools in India to that in Jamaica?
Your answer should be very brief. 0.82. What is the ratio of the Gross enrolment ratio (%) in Secondary schools in India to that in Jamaica?
Provide a succinct answer. 2.17. What is the ratio of the Gross enrolment ratio (%) in Tertiary schools in India to that in Jamaica?
Give a very brief answer. 1.41. What is the ratio of the Gross enrolment ratio (%) in Pre-primary schools in Iran to that in Ireland?
Your answer should be compact. 0.11. What is the ratio of the Gross enrolment ratio (%) of Primary schools in Iran to that in Ireland?
Your answer should be very brief. 0.96. What is the ratio of the Gross enrolment ratio (%) of Secondary schools in Iran to that in Ireland?
Keep it short and to the point. 17.63. What is the ratio of the Gross enrolment ratio (%) of Tertiary schools in Iran to that in Ireland?
Ensure brevity in your answer.  1.24. What is the ratio of the Gross enrolment ratio (%) of Pre-primary schools in Iran to that in Italy?
Provide a succinct answer. 0.12. What is the ratio of the Gross enrolment ratio (%) of Primary schools in Iran to that in Italy?
Provide a short and direct response. 3.29. What is the ratio of the Gross enrolment ratio (%) in Secondary schools in Iran to that in Italy?
Offer a very short reply. 1.1. What is the ratio of the Gross enrolment ratio (%) of Tertiary schools in Iran to that in Italy?
Offer a very short reply. 1.24. What is the ratio of the Gross enrolment ratio (%) of Pre-primary schools in Iran to that in Jamaica?
Provide a short and direct response. 0.15. What is the ratio of the Gross enrolment ratio (%) of Primary schools in Iran to that in Jamaica?
Provide a succinct answer. 0.94. What is the ratio of the Gross enrolment ratio (%) of Secondary schools in Iran to that in Jamaica?
Give a very brief answer. 2.24. What is the ratio of the Gross enrolment ratio (%) in Tertiary schools in Iran to that in Jamaica?
Provide a short and direct response. 1.23. What is the ratio of the Gross enrolment ratio (%) in Pre-primary schools in Ireland to that in Italy?
Your response must be concise. 1.08. What is the ratio of the Gross enrolment ratio (%) in Primary schools in Ireland to that in Italy?
Your answer should be very brief. 3.43. What is the ratio of the Gross enrolment ratio (%) of Secondary schools in Ireland to that in Italy?
Make the answer very short. 0.06. What is the ratio of the Gross enrolment ratio (%) of Pre-primary schools in Ireland to that in Jamaica?
Your response must be concise. 1.28. What is the ratio of the Gross enrolment ratio (%) in Primary schools in Ireland to that in Jamaica?
Ensure brevity in your answer.  0.98. What is the ratio of the Gross enrolment ratio (%) in Secondary schools in Ireland to that in Jamaica?
Provide a succinct answer. 0.13. What is the ratio of the Gross enrolment ratio (%) of Pre-primary schools in Italy to that in Jamaica?
Offer a terse response. 1.18. What is the ratio of the Gross enrolment ratio (%) in Primary schools in Italy to that in Jamaica?
Your answer should be compact. 0.28. What is the ratio of the Gross enrolment ratio (%) of Secondary schools in Italy to that in Jamaica?
Your response must be concise. 2.04. What is the difference between the highest and the second highest Gross enrolment ratio (%) in Pre-primary schools?
Your answer should be very brief. 7.76. What is the difference between the highest and the second highest Gross enrolment ratio (%) of Primary schools?
Provide a succinct answer. 2.27. What is the difference between the highest and the second highest Gross enrolment ratio (%) of Secondary schools?
Keep it short and to the point. 2.97. What is the difference between the highest and the second highest Gross enrolment ratio (%) in Tertiary schools?
Provide a succinct answer. 4.32. What is the difference between the highest and the lowest Gross enrolment ratio (%) of Pre-primary schools?
Keep it short and to the point. 97.78. What is the difference between the highest and the lowest Gross enrolment ratio (%) in Primary schools?
Give a very brief answer. 71.63. What is the difference between the highest and the lowest Gross enrolment ratio (%) of Secondary schools?
Your answer should be compact. 90.68. What is the difference between the highest and the lowest Gross enrolment ratio (%) of Tertiary schools?
Provide a succinct answer. 9.85. 